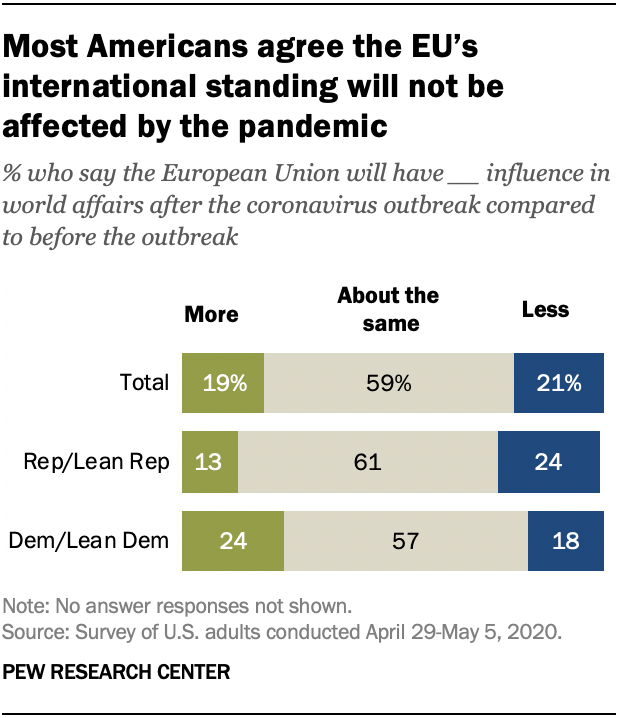List a handful of essential elements in this visual. The median value of gray bars is greater than the median value of green bars. The number of colors used to represent all the bars is 3. 